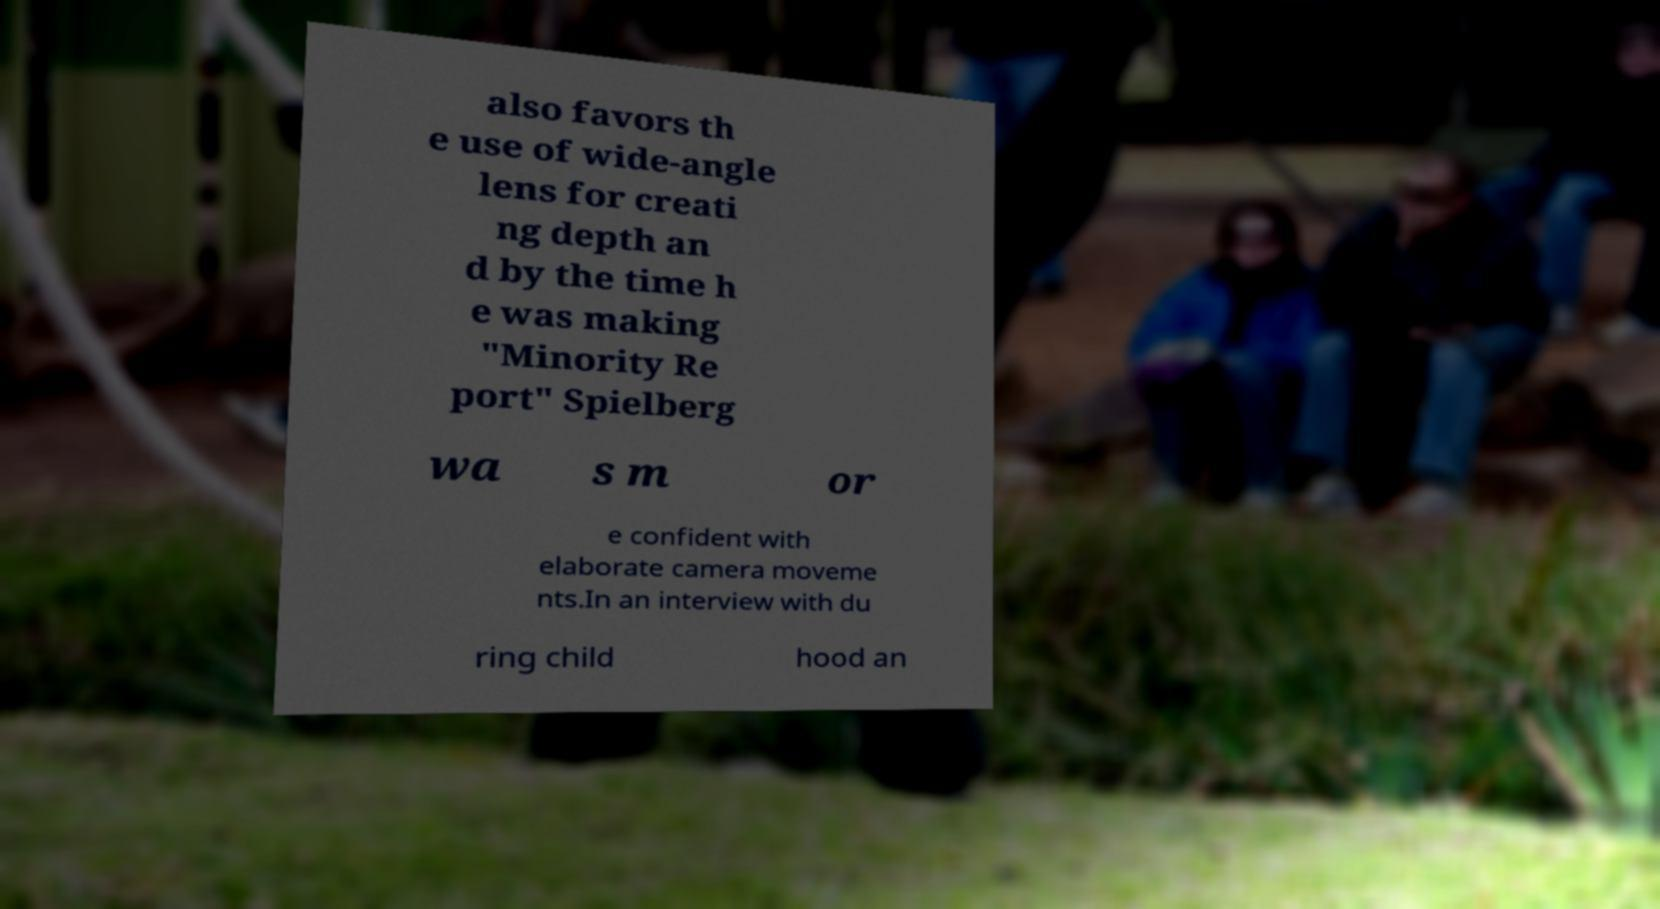Can you accurately transcribe the text from the provided image for me? also favors th e use of wide-angle lens for creati ng depth an d by the time h e was making "Minority Re port" Spielberg wa s m or e confident with elaborate camera moveme nts.In an interview with du ring child hood an 